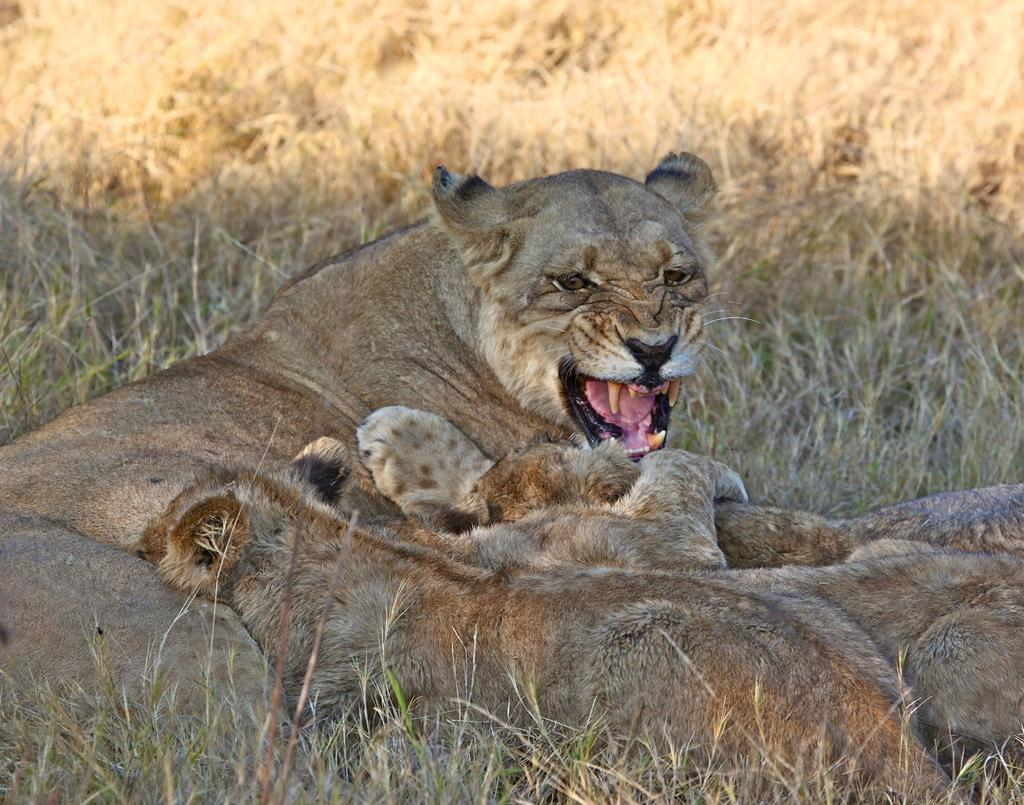What types of living organisms can be seen in the image? There are animals in the image. What type of vegetation is present in the image? There is dry grass in the image. What type of party is being held in the image? There is no party present in the image; it features animals and dry grass. What scientific discoveries can be observed in the image? There are no scientific discoveries depicted in the image; it simply shows animals and dry grass. 